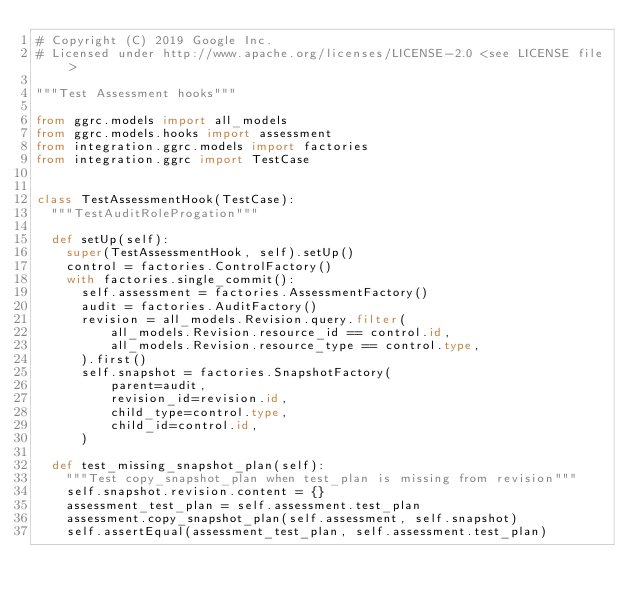<code> <loc_0><loc_0><loc_500><loc_500><_Python_># Copyright (C) 2019 Google Inc.
# Licensed under http://www.apache.org/licenses/LICENSE-2.0 <see LICENSE file>

"""Test Assessment hooks"""

from ggrc.models import all_models
from ggrc.models.hooks import assessment
from integration.ggrc.models import factories
from integration.ggrc import TestCase


class TestAssessmentHook(TestCase):
  """TestAuditRoleProgation"""

  def setUp(self):
    super(TestAssessmentHook, self).setUp()
    control = factories.ControlFactory()
    with factories.single_commit():
      self.assessment = factories.AssessmentFactory()
      audit = factories.AuditFactory()
      revision = all_models.Revision.query.filter(
          all_models.Revision.resource_id == control.id,
          all_models.Revision.resource_type == control.type,
      ).first()
      self.snapshot = factories.SnapshotFactory(
          parent=audit,
          revision_id=revision.id,
          child_type=control.type,
          child_id=control.id,
      )

  def test_missing_snapshot_plan(self):
    """Test copy_snapshot_plan when test_plan is missing from revision"""
    self.snapshot.revision.content = {}
    assessment_test_plan = self.assessment.test_plan
    assessment.copy_snapshot_plan(self.assessment, self.snapshot)
    self.assertEqual(assessment_test_plan, self.assessment.test_plan)
</code> 